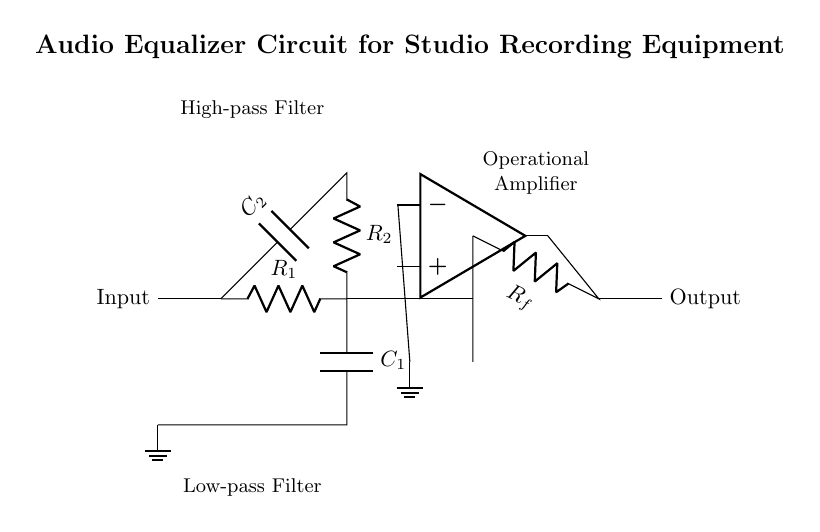What type of filters are used in this circuit? The circuit contains both a low-pass filter, which allows signals with a frequency lower than a certain cutoff frequency to pass, and a high-pass filter, which allows signals with a frequency higher than a certain cutoff frequency.
Answer: Low-pass and high-pass What is the purpose of the operational amplifier in this circuit? The operational amplifier in the circuit is used to amplify the filtered signals. It takes the output from the filters and increases the signal strength for the output.
Answer: Amplification How many resistors and capacitors are present in the circuit? In the circuit, there are two resistors (R1 and R2) and two capacitors (C1 and C2), which form the filter networks.
Answer: Two resistors and two capacitors Which component is used to achieve signal feedback in the circuit? The resistor denoted as Rf is used to achieve feedback by providing a pathway from the output of the operational amplifier back to its inverting terminal, enhancing stability and gain in the circuit.
Answer: Rf What is the function of the ground symbols in the circuit? The ground symbols in the circuit serve as the reference point for voltage measurements, establishing a common return path for current and providing a stable reference level for the circuit's operation.
Answer: Reference point What defines the signal flow direction in this audio equalizer circuit? The signal flows from the input on the left, passing through the filters and the operational amplifier, and ultimately reaching the output on the right, indicating a clear directional flow of audio processing from input to output.
Answer: Left to right 